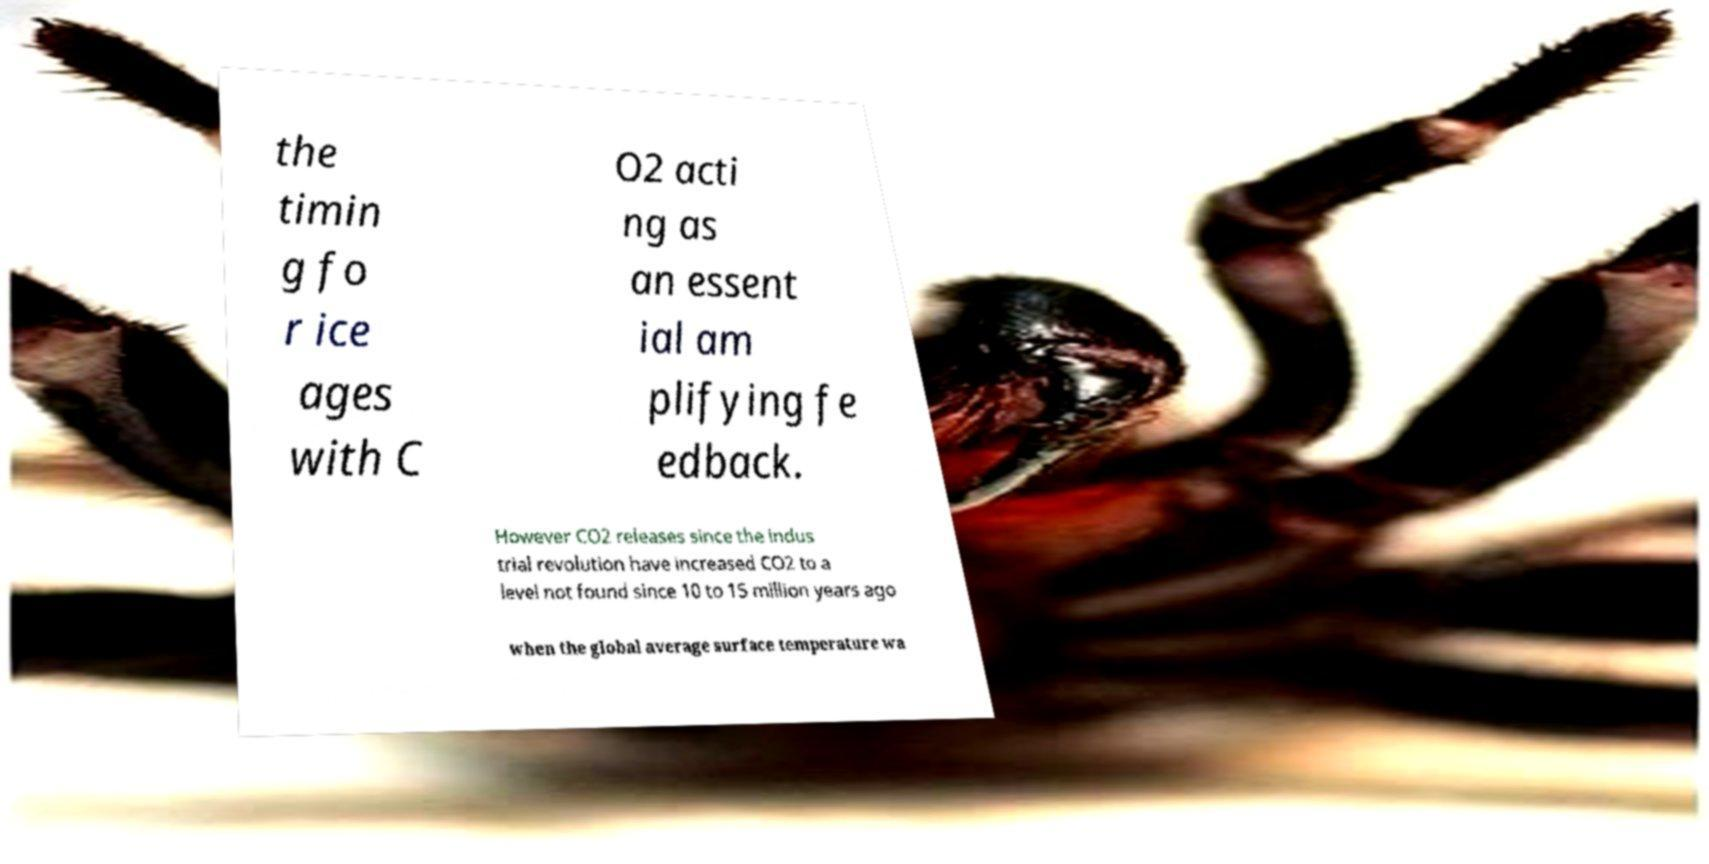Could you extract and type out the text from this image? the timin g fo r ice ages with C O2 acti ng as an essent ial am plifying fe edback. However CO2 releases since the indus trial revolution have increased CO2 to a level not found since 10 to 15 million years ago when the global average surface temperature wa 